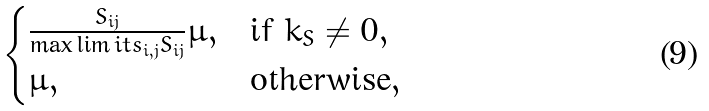Convert formula to latex. <formula><loc_0><loc_0><loc_500><loc_500>\begin{cases} \frac { S _ { i j } } { \max \lim i t s _ { i , j } S _ { i j } } \mu , & \text {if } k _ { S } \neq 0 , \\ \mu , & \text {otherwise} , \end{cases}</formula> 